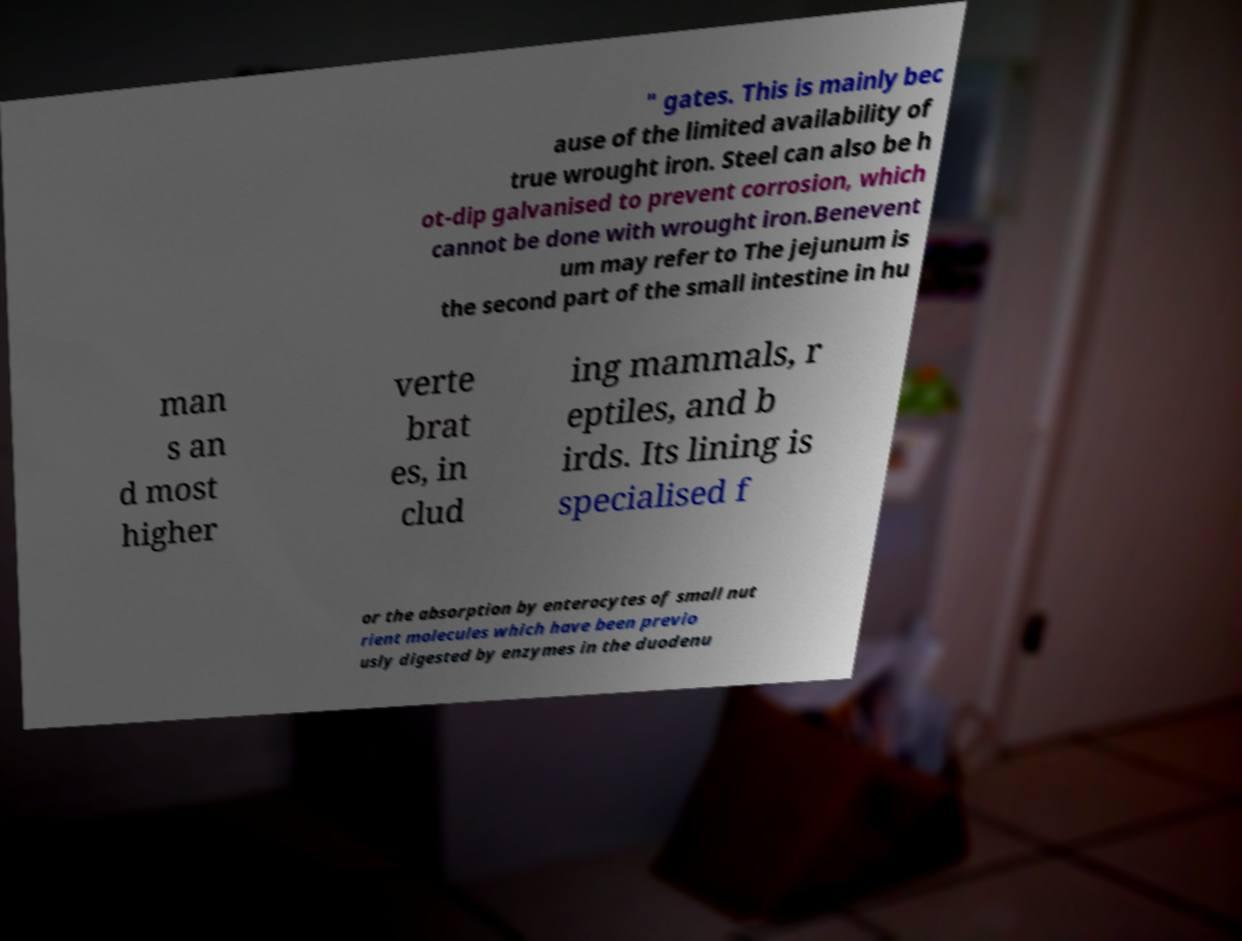Can you accurately transcribe the text from the provided image for me? " gates. This is mainly bec ause of the limited availability of true wrought iron. Steel can also be h ot-dip galvanised to prevent corrosion, which cannot be done with wrought iron.Benevent um may refer to The jejunum is the second part of the small intestine in hu man s an d most higher verte brat es, in clud ing mammals, r eptiles, and b irds. Its lining is specialised f or the absorption by enterocytes of small nut rient molecules which have been previo usly digested by enzymes in the duodenu 